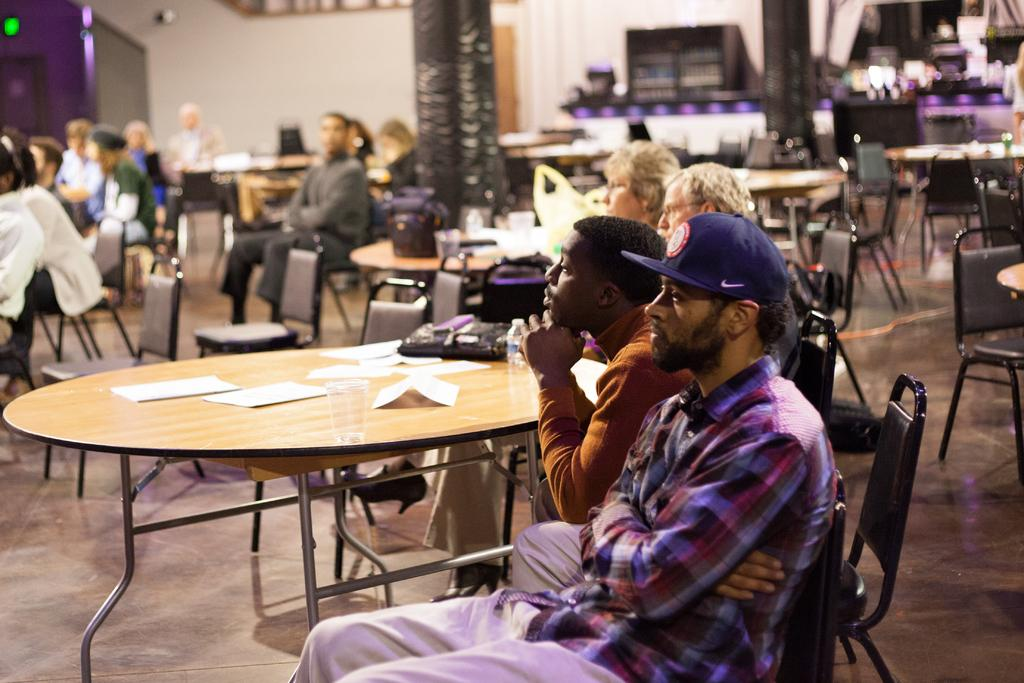What are the people in the image doing? The people in the image are sitting on the table. Are there any empty chairs in the image? Yes, there are unoccupied chairs in the image. What can be seen in the background of the image? Beautiful curtains are visible in the background. What type of oil is being used to copy the curtains in the image? There is no oil or copying activity present in the image; people are sitting on the table, and beautiful curtains are visible in the background. 